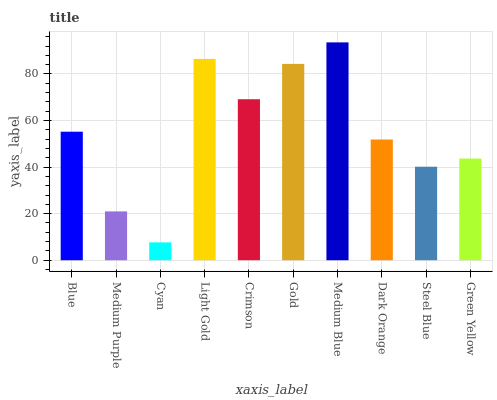Is Cyan the minimum?
Answer yes or no. Yes. Is Medium Blue the maximum?
Answer yes or no. Yes. Is Medium Purple the minimum?
Answer yes or no. No. Is Medium Purple the maximum?
Answer yes or no. No. Is Blue greater than Medium Purple?
Answer yes or no. Yes. Is Medium Purple less than Blue?
Answer yes or no. Yes. Is Medium Purple greater than Blue?
Answer yes or no. No. Is Blue less than Medium Purple?
Answer yes or no. No. Is Blue the high median?
Answer yes or no. Yes. Is Dark Orange the low median?
Answer yes or no. Yes. Is Crimson the high median?
Answer yes or no. No. Is Steel Blue the low median?
Answer yes or no. No. 